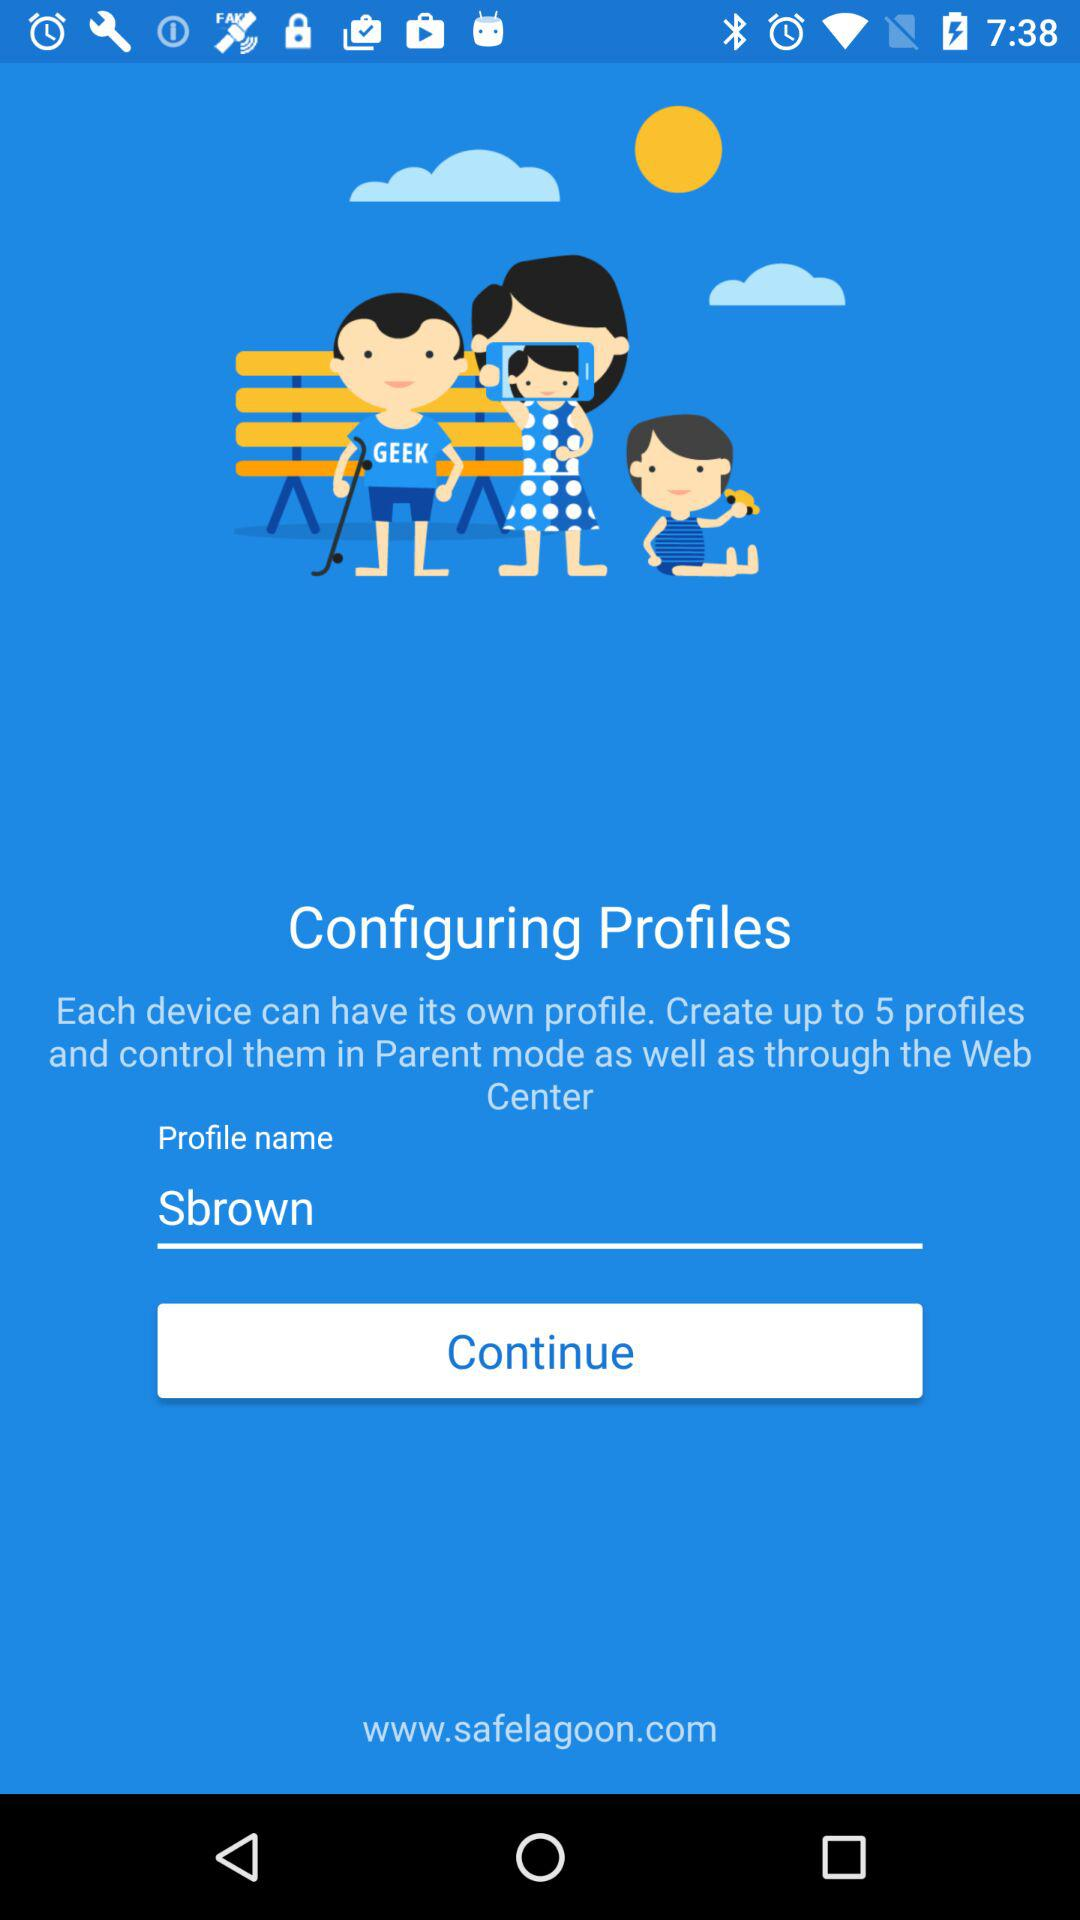What is the profile name? The profile name is Sbrown. 